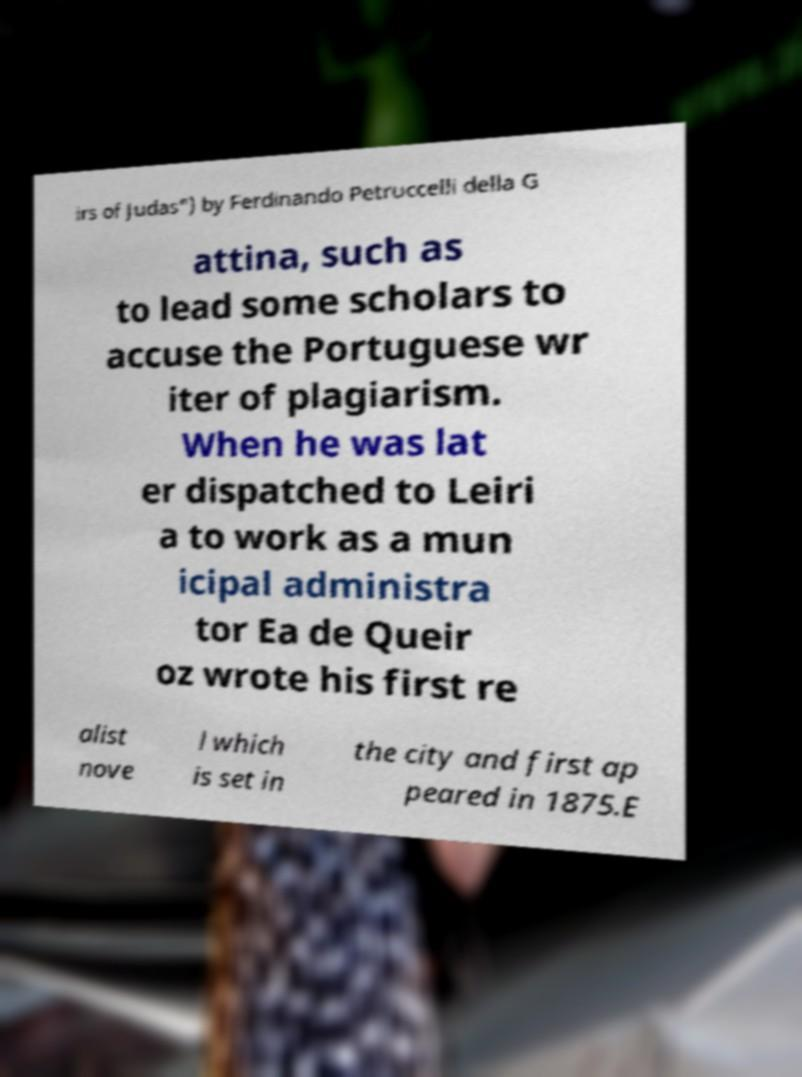What messages or text are displayed in this image? I need them in a readable, typed format. irs of Judas") by Ferdinando Petruccelli della G attina, such as to lead some scholars to accuse the Portuguese wr iter of plagiarism. When he was lat er dispatched to Leiri a to work as a mun icipal administra tor Ea de Queir oz wrote his first re alist nove l which is set in the city and first ap peared in 1875.E 